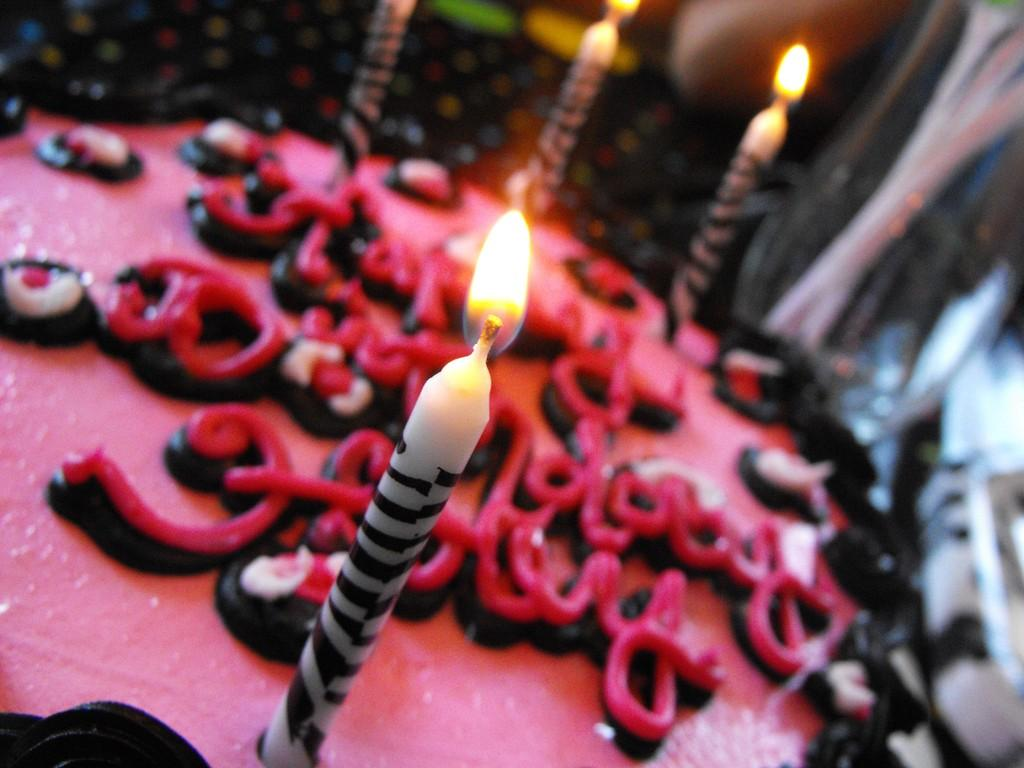What is the main subject of the image? The main subject of the image is a cake. What is placed on top of the cake? There are candles in the image. What type of plants can be seen growing in the shape of the cake in the image? There are no plants present in the image, and the cake is not in the shape of any plants. 